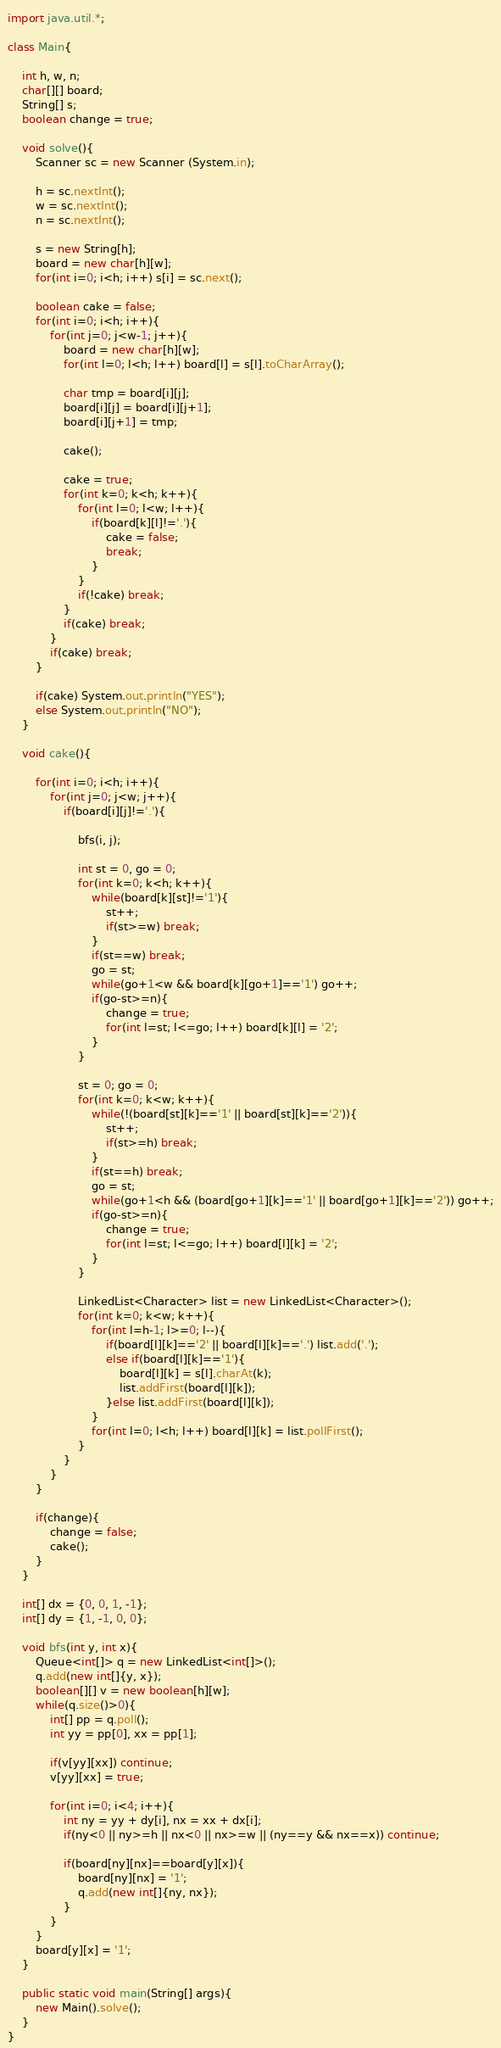Convert code to text. <code><loc_0><loc_0><loc_500><loc_500><_Java_>import java.util.*;

class Main{

    int h, w, n;
    char[][] board;
    String[] s;
    boolean change = true;

    void solve(){
        Scanner sc = new Scanner (System.in);

        h = sc.nextInt();
        w = sc.nextInt();
        n = sc.nextInt();

        s = new String[h];
        board = new char[h][w];
        for(int i=0; i<h; i++) s[i] = sc.next();

        boolean cake = false;
        for(int i=0; i<h; i++){
            for(int j=0; j<w-1; j++){
                board = new char[h][w];
                for(int l=0; l<h; l++) board[l] = s[l].toCharArray();
                             
                char tmp = board[i][j];
                board[i][j] = board[i][j+1];
                board[i][j+1] = tmp;
        
                cake();

                cake = true;
                for(int k=0; k<h; k++){
                    for(int l=0; l<w; l++){
                        if(board[k][l]!='.'){
                            cake = false;
                            break;
                        }
                    }
                    if(!cake) break;
                }
                if(cake) break;
            }
            if(cake) break;
        }

        if(cake) System.out.println("YES");
        else System.out.println("NO");
    }

    void cake(){

        for(int i=0; i<h; i++){
            for(int j=0; j<w; j++){
                if(board[i][j]!='.'){

                    bfs(i, j);
                    
                    int st = 0, go = 0;
                    for(int k=0; k<h; k++){
                        while(board[k][st]!='1'){
                            st++;
                            if(st>=w) break;
                        }
                        if(st==w) break;
                        go = st;
                        while(go+1<w && board[k][go+1]=='1') go++;
                        if(go-st>=n){
                            change = true;
                            for(int l=st; l<=go; l++) board[k][l] = '2';
                        }
                    }

                    st = 0; go = 0;
                    for(int k=0; k<w; k++){
                        while(!(board[st][k]=='1' || board[st][k]=='2')){
                            st++;
                            if(st>=h) break;
                        }
                        if(st==h) break;
                        go = st;
                        while(go+1<h && (board[go+1][k]=='1' || board[go+1][k]=='2')) go++;
                        if(go-st>=n){
                            change = true;
                            for(int l=st; l<=go; l++) board[l][k] = '2';
                        }
                    }

                    LinkedList<Character> list = new LinkedList<Character>();
                    for(int k=0; k<w; k++){
                        for(int l=h-1; l>=0; l--){
                            if(board[l][k]=='2' || board[l][k]=='.') list.add('.');
                            else if(board[l][k]=='1'){
                                board[l][k] = s[l].charAt(k);
                                list.addFirst(board[l][k]);
                            }else list.addFirst(board[l][k]);
                        }
                        for(int l=0; l<h; l++) board[l][k] = list.pollFirst();
                    }
                }
            }
        }

        if(change){
            change = false;
            cake();
        }
    }

    int[] dx = {0, 0, 1, -1};
    int[] dy = {1, -1, 0, 0};

    void bfs(int y, int x){
        Queue<int[]> q = new LinkedList<int[]>();
        q.add(new int[]{y, x});
        boolean[][] v = new boolean[h][w];
        while(q.size()>0){
            int[] pp = q.poll();
            int yy = pp[0], xx = pp[1];

            if(v[yy][xx]) continue;
            v[yy][xx] = true;

            for(int i=0; i<4; i++){
                int ny = yy + dy[i], nx = xx + dx[i];
                if(ny<0 || ny>=h || nx<0 || nx>=w || (ny==y && nx==x)) continue;

                if(board[ny][nx]==board[y][x]){
                    board[ny][nx] = '1';
                    q.add(new int[]{ny, nx});
                }
            }
        }
        board[y][x] = '1';
    }

    public static void main(String[] args){
        new Main().solve();
    }
}</code> 